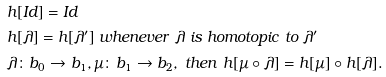<formula> <loc_0><loc_0><loc_500><loc_500>& h [ I d ] = I d \\ & h [ \lambda ] = h [ \lambda ^ { \prime } ] \ w h e n e v e r \ \lambda \ i s \ h o m o t o p i c \ t o \ \lambda ^ { \prime } \\ & \lambda \colon b _ { 0 } \rightarrow b _ { 1 } , \mu \colon b _ { 1 } \rightarrow b _ { 2 } , \ t h e n \ h [ \mu \circ \lambda ] = h [ \mu ] \circ h [ \lambda ] .</formula> 